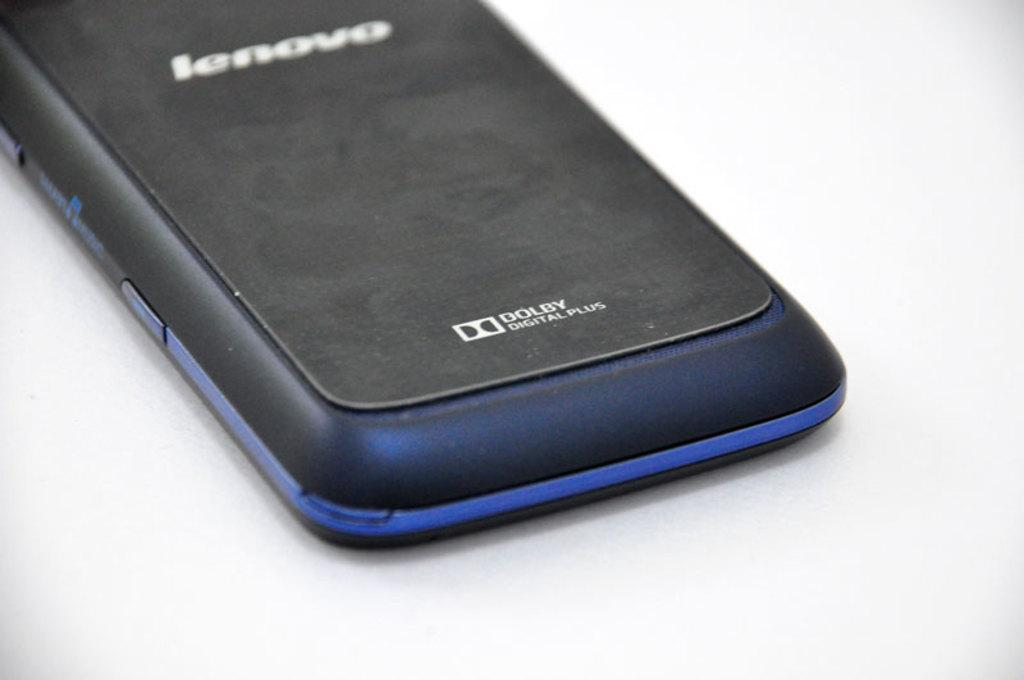<image>
Create a compact narrative representing the image presented. a lenovo phone with dolby written on the back and a blue tintish color 